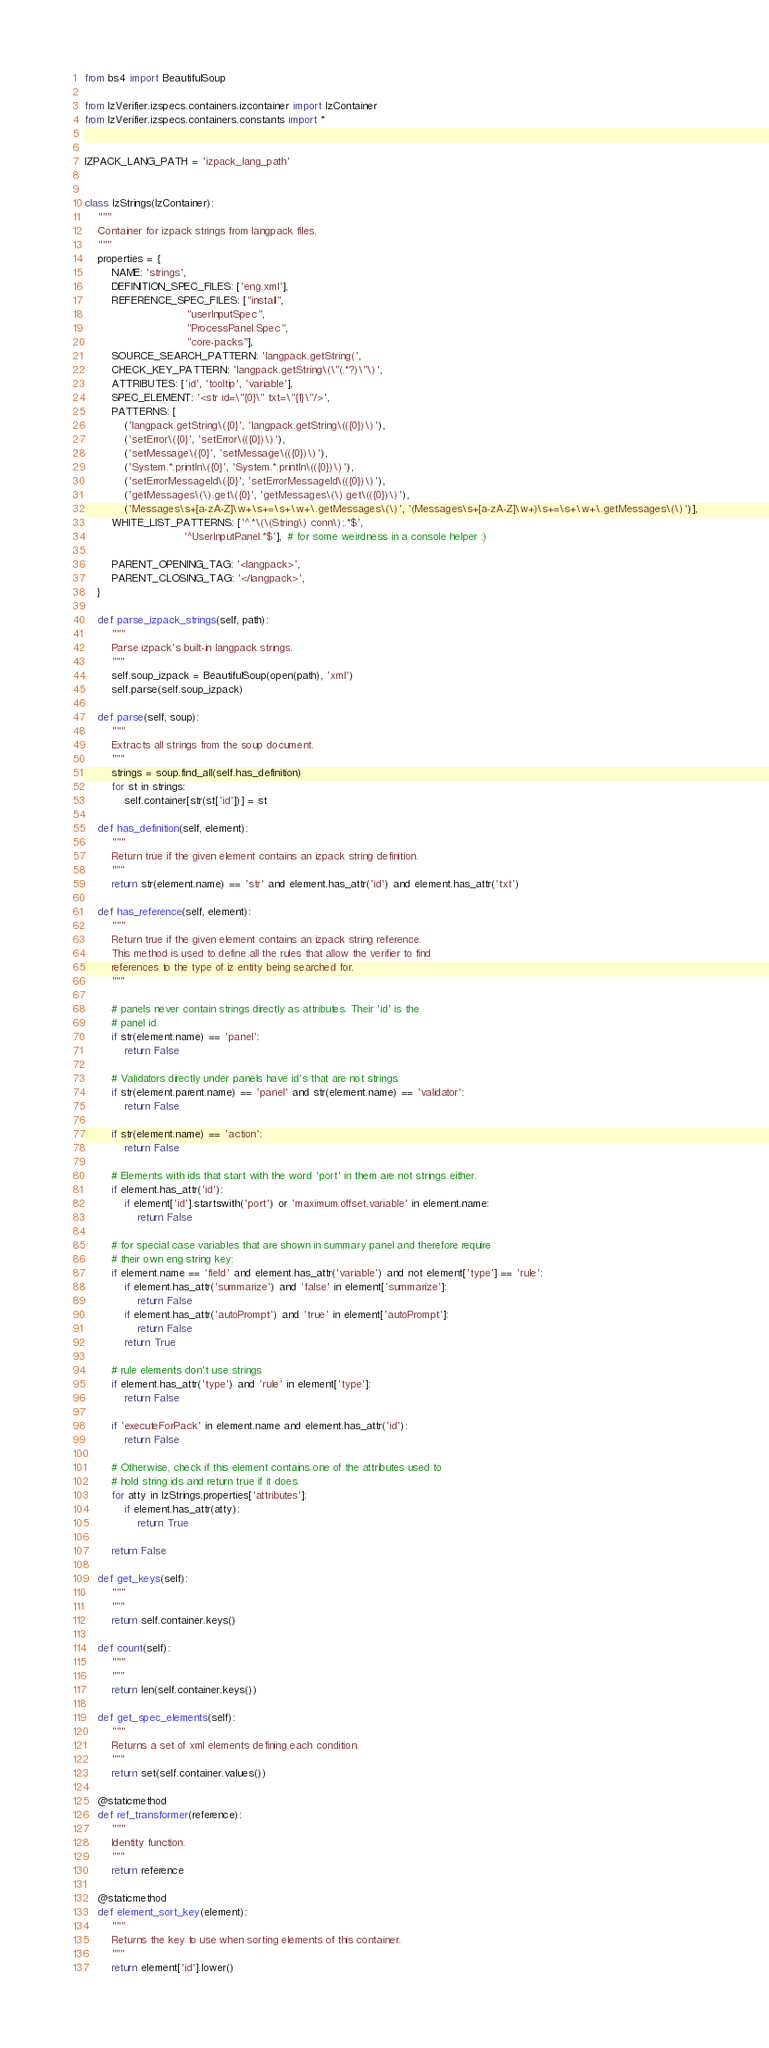Convert code to text. <code><loc_0><loc_0><loc_500><loc_500><_Python_>from bs4 import BeautifulSoup

from IzVerifier.izspecs.containers.izcontainer import IzContainer
from IzVerifier.izspecs.containers.constants import *


IZPACK_LANG_PATH = 'izpack_lang_path'


class IzStrings(IzContainer):
    """
    Container for izpack strings from langpack files.
    """
    properties = {
        NAME: 'strings',
        DEFINITION_SPEC_FILES: ['eng.xml'],
        REFERENCE_SPEC_FILES: ["install",
                               "userInputSpec",
                               "ProcessPanel.Spec",
                               "core-packs"],
        SOURCE_SEARCH_PATTERN: 'langpack.getString(',
        CHECK_KEY_PATTERN: 'langpack.getString\(\"(.*?)\"\)',
        ATTRIBUTES: ['id', 'tooltip', 'variable'],
        SPEC_ELEMENT: '<str id=\"{0}\" txt=\"{1}\"/>',
        PATTERNS: [
            ('langpack.getString\({0}', 'langpack.getString\(({0})\)'),
            ('setError\({0}', 'setError\(({0})\)'),
            ('setMessage\({0}', 'setMessage\(({0})\)'),
            ('System.*.println\({0}', 'System.*.println\(({0})\)'),
            ('setErrorMessageId\({0}', 'setErrorMessageId\(({0})\)'),
            ('getMessages\(\).get\({0}', 'getMessages\(\).get\(({0})\)'),
            ('Messages\s+[a-zA-Z]\w+\s+=\s+\w+\.getMessages\(\)', '(Messages\s+[a-zA-Z]\w+)\s+=\s+\w+\.getMessages\(\)')],
        WHITE_LIST_PATTERNS: ['^.*\(\(String\) conn\);.*$',
                              '^UserInputPanel.*$'],  # for some weirdness in a console helper :)

        PARENT_OPENING_TAG: '<langpack>',
        PARENT_CLOSING_TAG: '</langpack>',
    }

    def parse_izpack_strings(self, path):
        """
        Parse izpack's built-in langpack strings.
        """
        self.soup_izpack = BeautifulSoup(open(path), 'xml')
        self.parse(self.soup_izpack)

    def parse(self, soup):
        """
        Extracts all strings from the soup document.
        """
        strings = soup.find_all(self.has_definition)
        for st in strings:
            self.container[str(st['id'])] = st

    def has_definition(self, element):
        """
        Return true if the given element contains an izpack string definition.
        """
        return str(element.name) == 'str' and element.has_attr('id') and element.has_attr('txt')

    def has_reference(self, element):
        """
        Return true if the given element contains an izpack string reference.
        This method is used to define all the rules that allow the verifier to find
        references to the type of iz entity being searched for.
        """

        # panels never contain strings directly as attributes. Their 'id' is the
        # panel id.
        if str(element.name) == 'panel':
            return False

        # Validators directly under panels have id's that are not strings.
        if str(element.parent.name) == 'panel' and str(element.name) == 'validator':
            return False

        if str(element.name) == 'action':
            return False

        # Elements with ids that start with the word 'port' in them are not strings either.
        if element.has_attr('id'):
            if element['id'].startswith('port') or 'maximum.offset.variable' in element.name:
                return False

        # for special case variables that are shown in summary panel and therefore require
        # their own eng string key:
        if element.name == 'field' and element.has_attr('variable') and not element['type'] == 'rule':
            if element.has_attr('summarize') and 'false' in element['summarize']:
                return False
            if element.has_attr('autoPrompt') and 'true' in element['autoPrompt']:
                return False
            return True

        # rule elements don't use strings
        if element.has_attr('type') and 'rule' in element['type']:
            return False

        if 'executeForPack' in element.name and element.has_attr('id'):
            return False

        # Otherwise, check if this element contains one of the attributes used to
        # hold string ids and return true if it does.
        for atty in IzStrings.properties['attributes']:
            if element.has_attr(atty):
                return True

        return False

    def get_keys(self):
        """
        """
        return self.container.keys()

    def count(self):
        """
        """
        return len(self.container.keys())

    def get_spec_elements(self):
        """
        Returns a set of xml elements defining each condition.
        """
        return set(self.container.values())

    @staticmethod
    def ref_transformer(reference):
        """
        Identity function.
        """
        return reference

    @staticmethod
    def element_sort_key(element):
        """
        Returns the key to use when sorting elements of this container.
        """
        return element['id'].lower()
</code> 